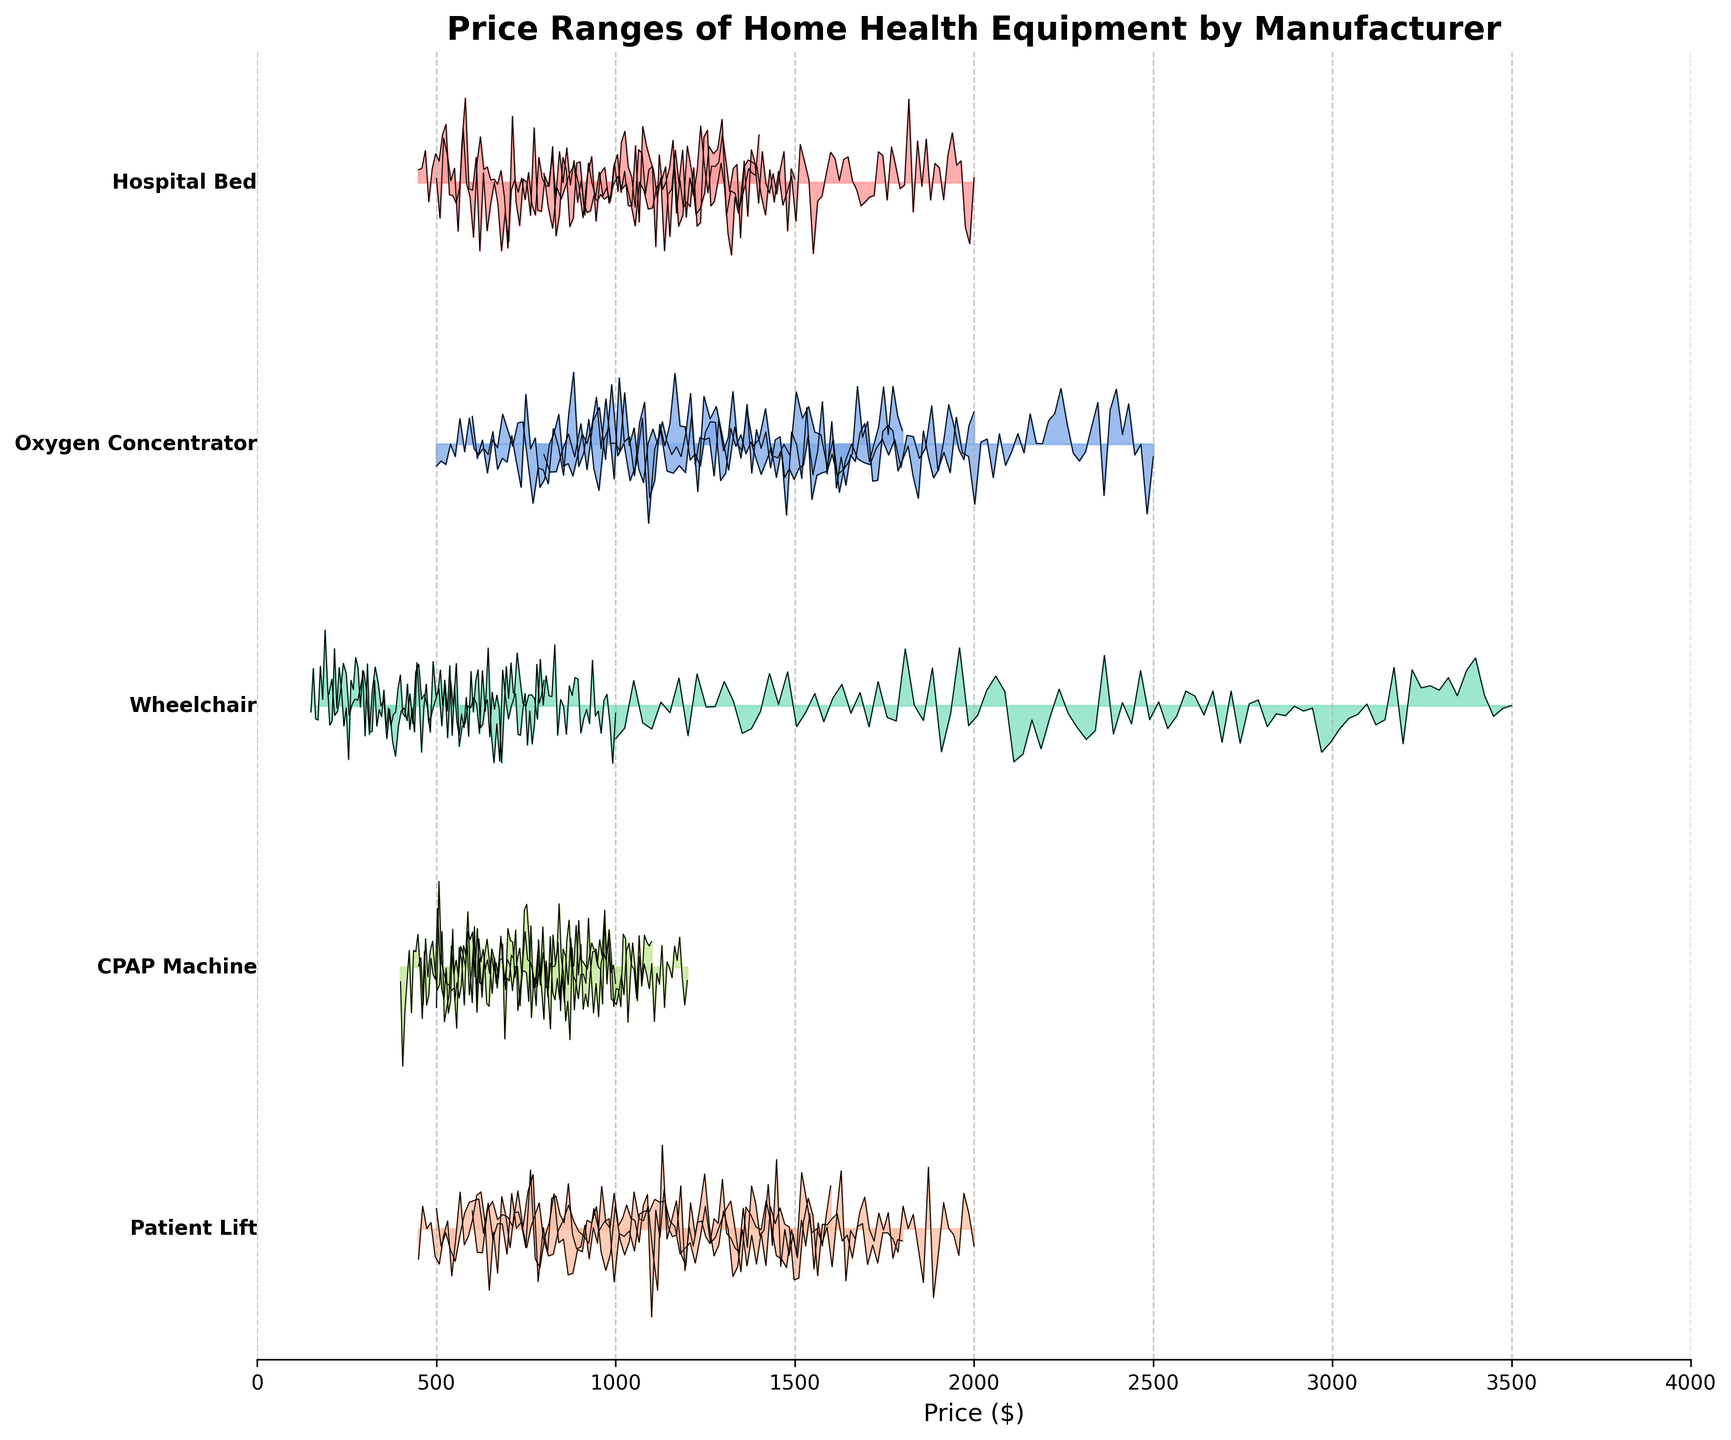what is the highest price range for the Oxygen Concentrator? To find the highest price range for the Oxygen Concentrator, we first locate it on the y-axis. Examining the plot, the price ranges for Philips Respironics, Inogen, and ResMed are 500-1800, 800-2500, and 600-2000 respectively. Among these, the highest price range is 800-2500.
Answer: 800-2500 which product has the lowest price among Patient Lift, Hospital Bed, and CPAP Machine? To answer this, we compare the lowest prices within each product's range. For Patient Lift, the lowest price is from Drive Medical at 450. For Hospital Bed, Drive Medical offers the lowest price at 450. For CPAP Machine, Fisher & Paykel has the lowest price at 400. Hence, CPAP Machine has the lowest price.
Answer: CPAP Machine which manufacturer offers the broadest price range for Wheelchair? To find the broadest price range for Wheelchair, we check the price differences for each manufacturer. The ranges are 200-1000 for Sunrise Medical, 1000-3500 for Permobil, and 150-800 for Invacare. Calculating the differences, we get 800, 2500, and 650 respectively. Permobil offers the broadest range at 2500.
Answer: Permobil what is the price range for Hoyer Patient Lift? Locate the Hoyer Patient Lift on the plot and read off the price range directly. The figure shows the range to be between 600 and 2000.
Answer: 600-2000 is the maximum price of the Philips Respironics Oxygen Concentrator higher than the ResMed CPAP Machine? Check the maximum prices for Philips Respironics Oxygen Concentrator and ResMed CPAP Machine. They are 1800 and 1200 respectively, so the answer is yes, 1800 is higher than 1200.
Answer: Yes which product shows the smallest range in prices across its manufacturers? Reviewing each product's price variation, Wheelchair by Invacare has the smallest range of 150-800 (difference of 650), while others have larger ranges.
Answer: Wheelchair does the Invacare manufacturer have consistent price ranges across different products? Examine the price ranges offered by Invacare. They are: Hospital Bed (500-1500), Oxygen Concentrator (not available for this), Wheelchair (150-800), Patient Lift (500-1800). These ranges vary significantly, indicating inconsistency.
Answer: No which CPAP Machine manufacturer has the lowest starting price? Identify the starting prices for CPAP Machine manufacturers. ResMed starts at 500, Philips Respironics at 450, and Fisher & Paykel at 400. The lowest starting price is 400.
Answer: Fisher & Paykel 